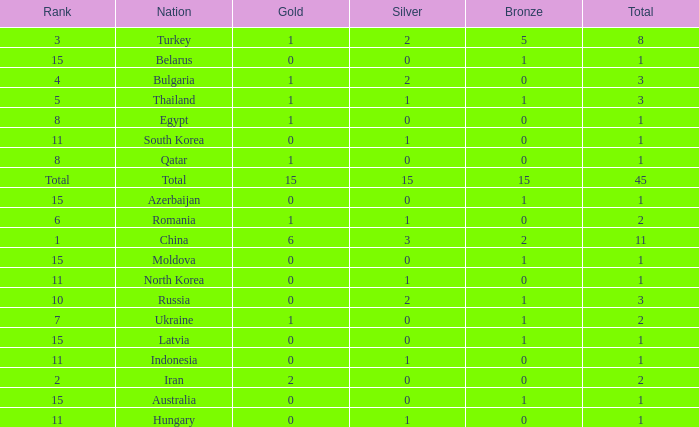What is the sum of the bronze medals of the nation with less than 0 silvers? None. Give me the full table as a dictionary. {'header': ['Rank', 'Nation', 'Gold', 'Silver', 'Bronze', 'Total'], 'rows': [['3', 'Turkey', '1', '2', '5', '8'], ['15', 'Belarus', '0', '0', '1', '1'], ['4', 'Bulgaria', '1', '2', '0', '3'], ['5', 'Thailand', '1', '1', '1', '3'], ['8', 'Egypt', '1', '0', '0', '1'], ['11', 'South Korea', '0', '1', '0', '1'], ['8', 'Qatar', '1', '0', '0', '1'], ['Total', 'Total', '15', '15', '15', '45'], ['15', 'Azerbaijan', '0', '0', '1', '1'], ['6', 'Romania', '1', '1', '0', '2'], ['1', 'China', '6', '3', '2', '11'], ['15', 'Moldova', '0', '0', '1', '1'], ['11', 'North Korea', '0', '1', '0', '1'], ['10', 'Russia', '0', '2', '1', '3'], ['7', 'Ukraine', '1', '0', '1', '2'], ['15', 'Latvia', '0', '0', '1', '1'], ['11', 'Indonesia', '0', '1', '0', '1'], ['2', 'Iran', '2', '0', '0', '2'], ['15', 'Australia', '0', '0', '1', '1'], ['11', 'Hungary', '0', '1', '0', '1']]} 